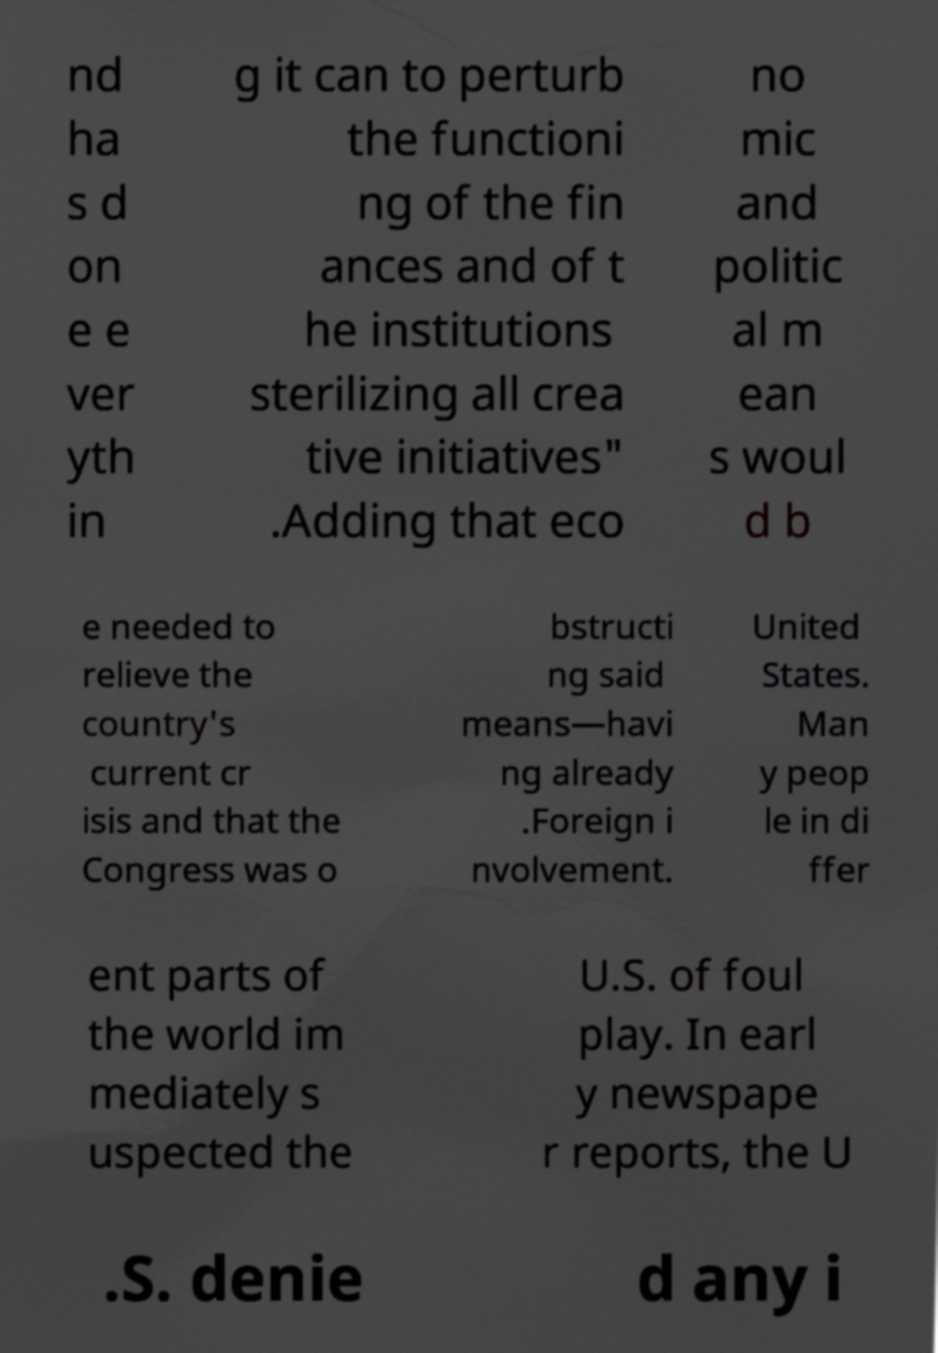Please identify and transcribe the text found in this image. nd ha s d on e e ver yth in g it can to perturb the functioni ng of the fin ances and of t he institutions sterilizing all crea tive initiatives" .Adding that eco no mic and politic al m ean s woul d b e needed to relieve the country's current cr isis and that the Congress was o bstructi ng said means—havi ng already .Foreign i nvolvement. United States. Man y peop le in di ffer ent parts of the world im mediately s uspected the U.S. of foul play. In earl y newspape r reports, the U .S. denie d any i 